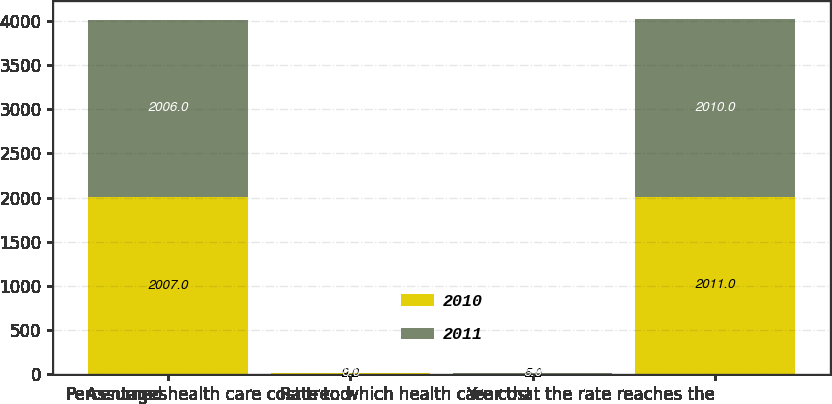Convert chart to OTSL. <chart><loc_0><loc_0><loc_500><loc_500><stacked_bar_chart><ecel><fcel>Percentages<fcel>Assumed health care cost trend<fcel>Rate to which health care cost<fcel>Year that the rate reaches the<nl><fcel>2010<fcel>2007<fcel>9<fcel>5<fcel>2011<nl><fcel>2011<fcel>2006<fcel>8<fcel>5<fcel>2010<nl></chart> 